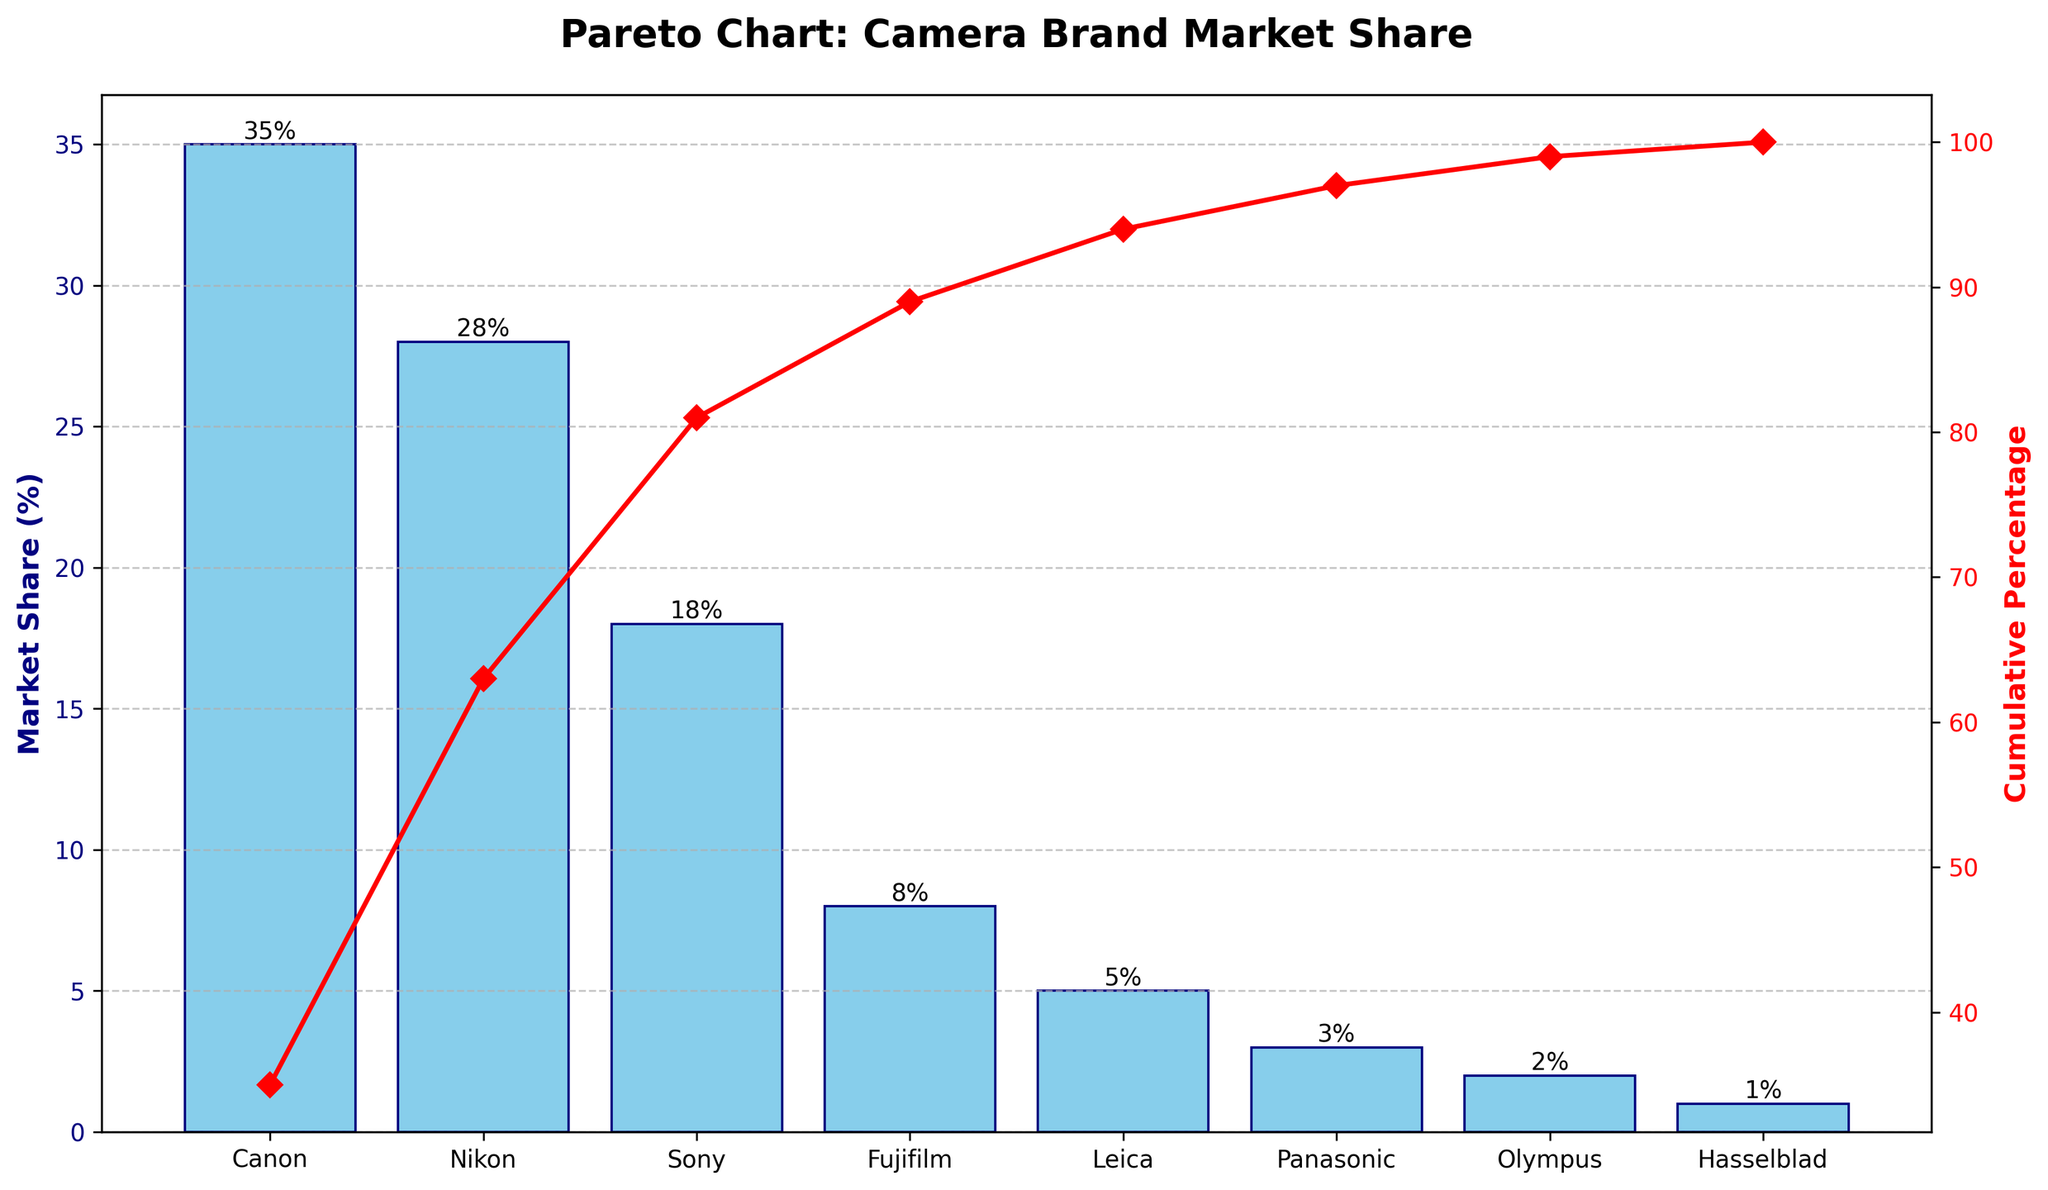Which camera brand holds the highest market share? The bar representing Canon is the tallest, indicating the highest market share.
Answer: Canon What's the cumulative percentage of the top three camera brands? Aggregate the market shares of Canon, Nikon, and Sony, which are 35%, 28%, and 18% respectively. Their cumulative percentage is (35 + 28 + 18) = 81%.
Answer: 81% How does the market share of Sony compare to that of Nikon? Nikon has a market share of 28%, while Sony has 18%. Comparing the two, Sony's market share is less than Nikon's by (28 - 18) = 10%.
Answer: Sony's share is 10% less than Nikon's What's the combined market share of Fujifilm, Leica, Panasonic, Olympus, and Hasselblad? Sum the market shares of these brands: Fujifilm (8%), Leica (5%), Panasonic (3%), Olympus (2%), and Hasselblad (1%). The combined market share is (8 + 5 + 3 + 2 + 1) = 19%.
Answer: 19% What is the total percentage covered by Canon and Nikon? Add the market shares of Canon and Nikon, 35% and 28% respectively. The total is (35 + 28) = 63%.
Answer: 63% What's the difference in market share between the top brand and the brand with the least market share? Canon's market share is 35%, and Hasselblad's is 1%. The difference is (35 - 1) = 34%.
Answer: 34% What percentage of the market do the non-top-three brands (brands ranked 4th and below) cover? Subtract the market share of the top three brands (81%) from the total market share (100%). The remaining percentage is (100 - 81) = 19%.
Answer: 19% How much more market share does Canon have compared to Sony and Fujifilm combined? Sony and Fujifilm combined have (18% + 8%) = 26%. Canon has 35%, so it has (35 - 26) = 9% more market share.
Answer: 9% At which brand does the cumulative market share surpass 90%? Calculate cumulative percentages: Canon (35%), Canon+Nikon (63%), Canon+Nikon+Sony (81%), Canon+Nikon+Sony+Fujifilm (89%), Canon+Nikon+Sony+Fujifilm+Leica (94%). The cumulative percentage surpasses 90% after adding Leica.
Answer: Leica What does the red line on the chart represent? The red line represents the cumulative percentage of the market share for the brands listed.
Answer: Cumulative percentage 